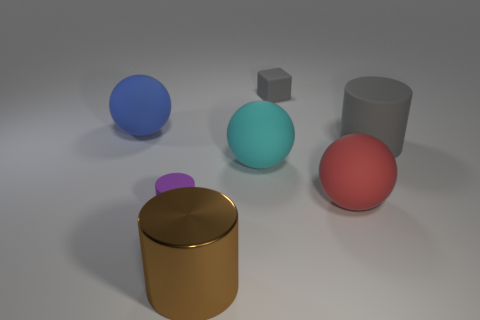Are there any other things that have the same material as the big brown object?
Provide a short and direct response. No. Is the number of big red objects that are behind the purple rubber cylinder greater than the number of tiny gray things that are to the right of the small gray cube?
Give a very brief answer. Yes. What number of blocks are large shiny objects or big blue rubber objects?
Provide a short and direct response. 0. There is a thing that is in front of the small purple matte cylinder; is it the same shape as the big gray matte object?
Give a very brief answer. Yes. What color is the metallic thing?
Provide a succinct answer. Brown. There is a small matte thing that is the same shape as the big gray rubber object; what color is it?
Give a very brief answer. Purple. How many big green matte things are the same shape as the tiny purple object?
Provide a short and direct response. 0. How many things are either large gray rubber objects or things that are right of the small matte block?
Give a very brief answer. 2. Is the color of the tiny cylinder the same as the large thing that is to the right of the big red sphere?
Provide a short and direct response. No. How big is the thing that is in front of the cyan matte sphere and to the right of the cyan matte sphere?
Keep it short and to the point. Large. 